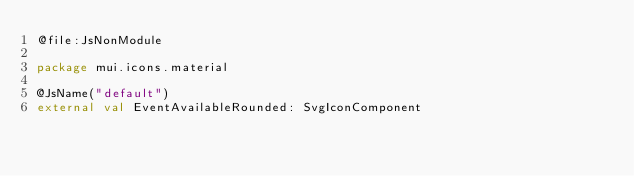Convert code to text. <code><loc_0><loc_0><loc_500><loc_500><_Kotlin_>@file:JsNonModule

package mui.icons.material

@JsName("default")
external val EventAvailableRounded: SvgIconComponent
</code> 